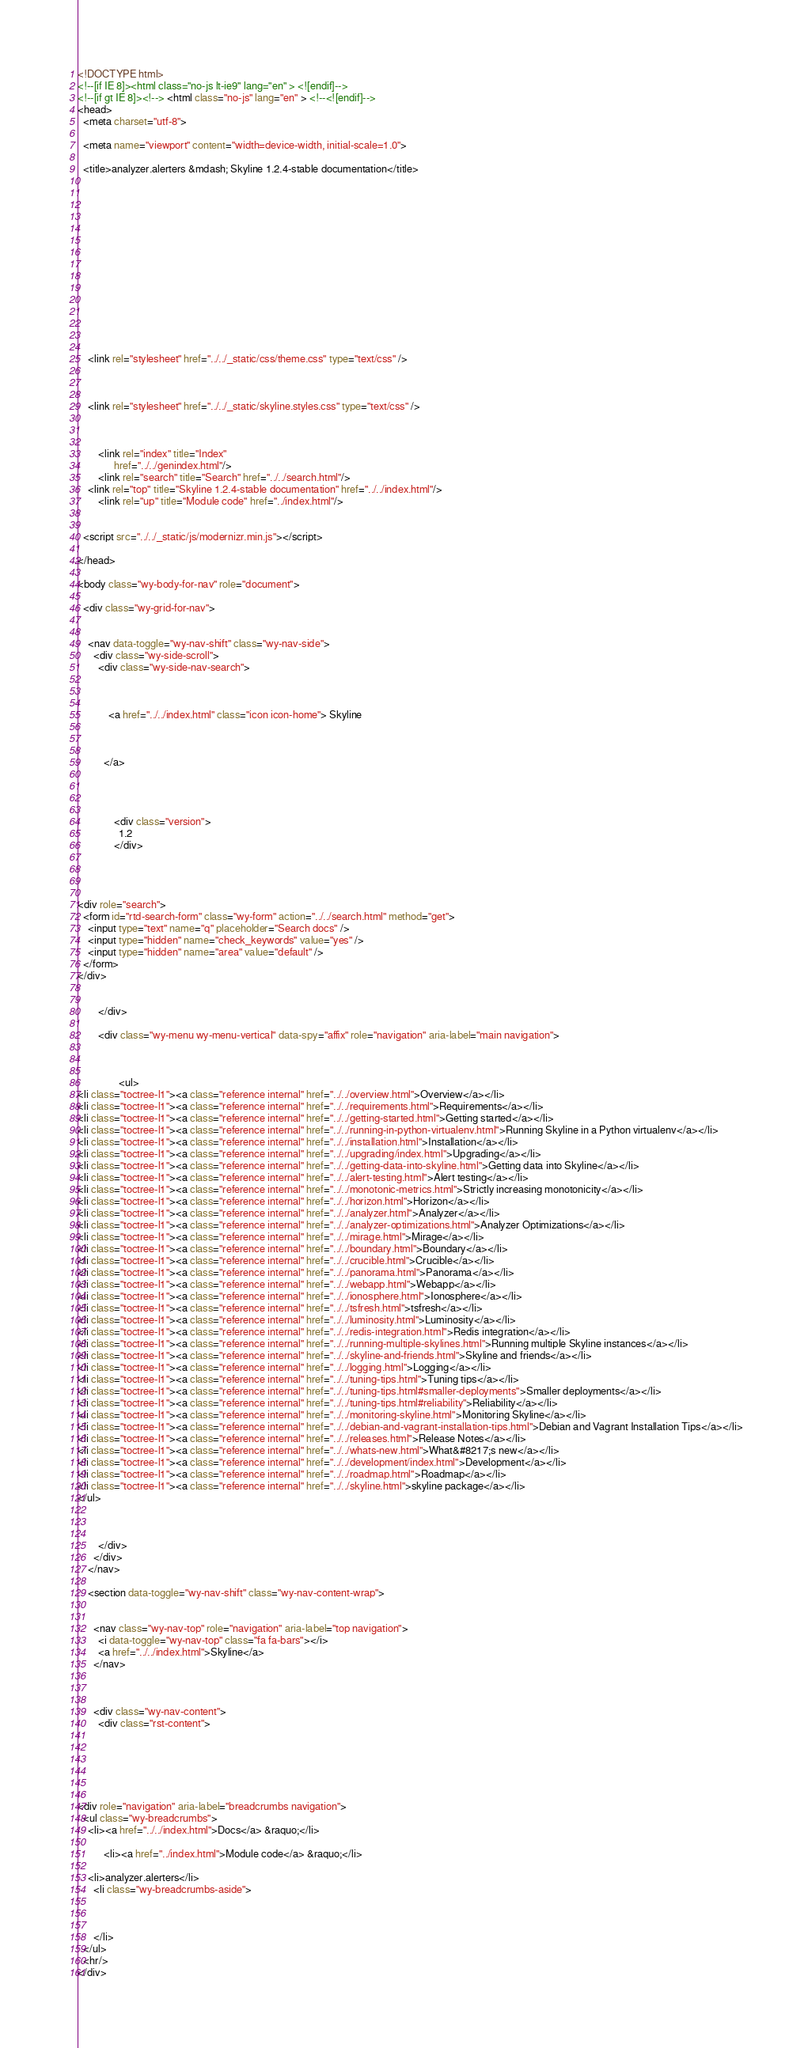Convert code to text. <code><loc_0><loc_0><loc_500><loc_500><_HTML_>

<!DOCTYPE html>
<!--[if IE 8]><html class="no-js lt-ie9" lang="en" > <![endif]-->
<!--[if gt IE 8]><!--> <html class="no-js" lang="en" > <!--<![endif]-->
<head>
  <meta charset="utf-8">
  
  <meta name="viewport" content="width=device-width, initial-scale=1.0">
  
  <title>analyzer.alerters &mdash; Skyline 1.2.4-stable documentation</title>
  

  
  

  

  
  
    

  

  
  
    <link rel="stylesheet" href="../../_static/css/theme.css" type="text/css" />
  

  
    <link rel="stylesheet" href="../../_static/skyline.styles.css" type="text/css" />
  

  
        <link rel="index" title="Index"
              href="../../genindex.html"/>
        <link rel="search" title="Search" href="../../search.html"/>
    <link rel="top" title="Skyline 1.2.4-stable documentation" href="../../index.html"/>
        <link rel="up" title="Module code" href="../index.html"/> 

  
  <script src="../../_static/js/modernizr.min.js"></script>

</head>

<body class="wy-body-for-nav" role="document">

  <div class="wy-grid-for-nav">

    
    <nav data-toggle="wy-nav-shift" class="wy-nav-side">
      <div class="wy-side-scroll">
        <div class="wy-side-nav-search">
          

          
            <a href="../../index.html" class="icon icon-home"> Skyline
          

          
          </a>

          
            
            
              <div class="version">
                1.2
              </div>
            
          

          
<div role="search">
  <form id="rtd-search-form" class="wy-form" action="../../search.html" method="get">
    <input type="text" name="q" placeholder="Search docs" />
    <input type="hidden" name="check_keywords" value="yes" />
    <input type="hidden" name="area" value="default" />
  </form>
</div>

          
        </div>

        <div class="wy-menu wy-menu-vertical" data-spy="affix" role="navigation" aria-label="main navigation">
          
            
            
                <ul>
<li class="toctree-l1"><a class="reference internal" href="../../overview.html">Overview</a></li>
<li class="toctree-l1"><a class="reference internal" href="../../requirements.html">Requirements</a></li>
<li class="toctree-l1"><a class="reference internal" href="../../getting-started.html">Getting started</a></li>
<li class="toctree-l1"><a class="reference internal" href="../../running-in-python-virtualenv.html">Running Skyline in a Python virtualenv</a></li>
<li class="toctree-l1"><a class="reference internal" href="../../installation.html">Installation</a></li>
<li class="toctree-l1"><a class="reference internal" href="../../upgrading/index.html">Upgrading</a></li>
<li class="toctree-l1"><a class="reference internal" href="../../getting-data-into-skyline.html">Getting data into Skyline</a></li>
<li class="toctree-l1"><a class="reference internal" href="../../alert-testing.html">Alert testing</a></li>
<li class="toctree-l1"><a class="reference internal" href="../../monotonic-metrics.html">Strictly increasing monotonicity</a></li>
<li class="toctree-l1"><a class="reference internal" href="../../horizon.html">Horizon</a></li>
<li class="toctree-l1"><a class="reference internal" href="../../analyzer.html">Analyzer</a></li>
<li class="toctree-l1"><a class="reference internal" href="../../analyzer-optimizations.html">Analyzer Optimizations</a></li>
<li class="toctree-l1"><a class="reference internal" href="../../mirage.html">Mirage</a></li>
<li class="toctree-l1"><a class="reference internal" href="../../boundary.html">Boundary</a></li>
<li class="toctree-l1"><a class="reference internal" href="../../crucible.html">Crucible</a></li>
<li class="toctree-l1"><a class="reference internal" href="../../panorama.html">Panorama</a></li>
<li class="toctree-l1"><a class="reference internal" href="../../webapp.html">Webapp</a></li>
<li class="toctree-l1"><a class="reference internal" href="../../ionosphere.html">Ionosphere</a></li>
<li class="toctree-l1"><a class="reference internal" href="../../tsfresh.html">tsfresh</a></li>
<li class="toctree-l1"><a class="reference internal" href="../../luminosity.html">Luminosity</a></li>
<li class="toctree-l1"><a class="reference internal" href="../../redis-integration.html">Redis integration</a></li>
<li class="toctree-l1"><a class="reference internal" href="../../running-multiple-skylines.html">Running multiple Skyline instances</a></li>
<li class="toctree-l1"><a class="reference internal" href="../../skyline-and-friends.html">Skyline and friends</a></li>
<li class="toctree-l1"><a class="reference internal" href="../../logging.html">Logging</a></li>
<li class="toctree-l1"><a class="reference internal" href="../../tuning-tips.html">Tuning tips</a></li>
<li class="toctree-l1"><a class="reference internal" href="../../tuning-tips.html#smaller-deployments">Smaller deployments</a></li>
<li class="toctree-l1"><a class="reference internal" href="../../tuning-tips.html#reliability">Reliability</a></li>
<li class="toctree-l1"><a class="reference internal" href="../../monitoring-skyline.html">Monitoring Skyline</a></li>
<li class="toctree-l1"><a class="reference internal" href="../../debian-and-vagrant-installation-tips.html">Debian and Vagrant Installation Tips</a></li>
<li class="toctree-l1"><a class="reference internal" href="../../releases.html">Release Notes</a></li>
<li class="toctree-l1"><a class="reference internal" href="../../whats-new.html">What&#8217;s new</a></li>
<li class="toctree-l1"><a class="reference internal" href="../../development/index.html">Development</a></li>
<li class="toctree-l1"><a class="reference internal" href="../../roadmap.html">Roadmap</a></li>
<li class="toctree-l1"><a class="reference internal" href="../../skyline.html">skyline package</a></li>
</ul>

            
          
        </div>
      </div>
    </nav>

    <section data-toggle="wy-nav-shift" class="wy-nav-content-wrap">

      
      <nav class="wy-nav-top" role="navigation" aria-label="top navigation">
        <i data-toggle="wy-nav-top" class="fa fa-bars"></i>
        <a href="../../index.html">Skyline</a>
      </nav>


      
      <div class="wy-nav-content">
        <div class="rst-content">
          





<div role="navigation" aria-label="breadcrumbs navigation">
  <ul class="wy-breadcrumbs">
    <li><a href="../../index.html">Docs</a> &raquo;</li>
      
          <li><a href="../index.html">Module code</a> &raquo;</li>
      
    <li>analyzer.alerters</li>
      <li class="wy-breadcrumbs-aside">
        
          
        
      </li>
  </ul>
  <hr/>
</div></code> 